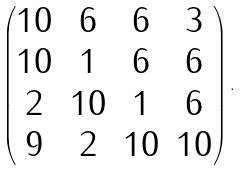<formula> <loc_0><loc_0><loc_500><loc_500>\begin{pmatrix} 1 0 & 6 & 6 & 3 \\ 1 0 & 1 & 6 & 6 \\ 2 & 1 0 & 1 & 6 \\ 9 & 2 & 1 0 & 1 0 \end{pmatrix} .</formula> 